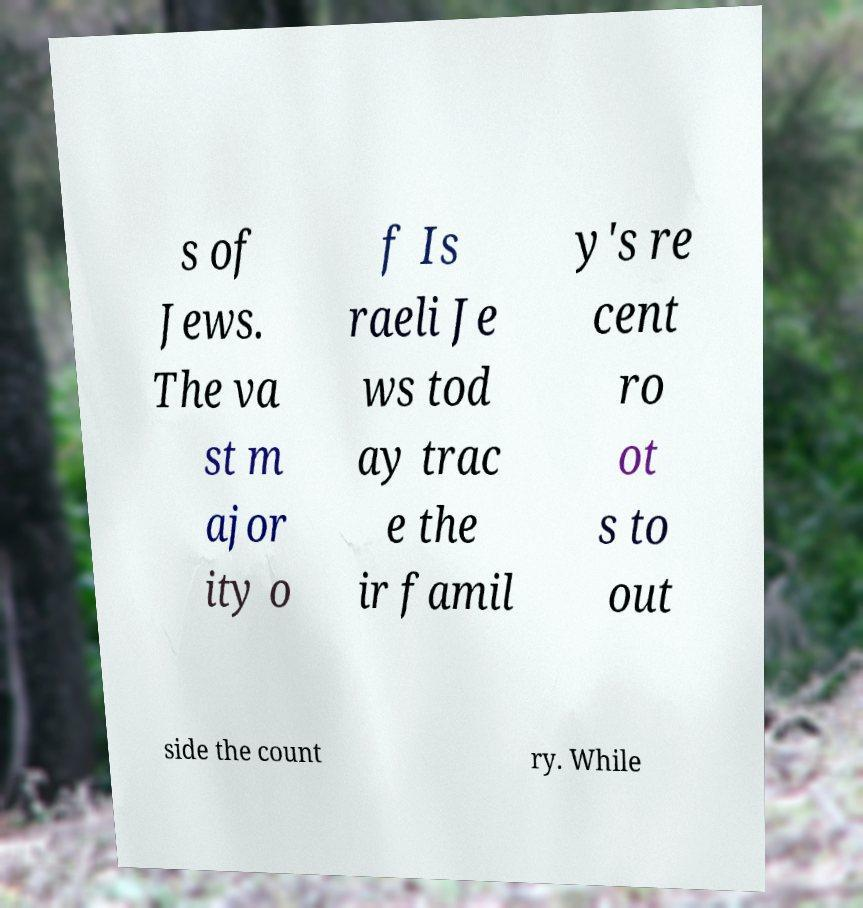For documentation purposes, I need the text within this image transcribed. Could you provide that? s of Jews. The va st m ajor ity o f Is raeli Je ws tod ay trac e the ir famil y's re cent ro ot s to out side the count ry. While 